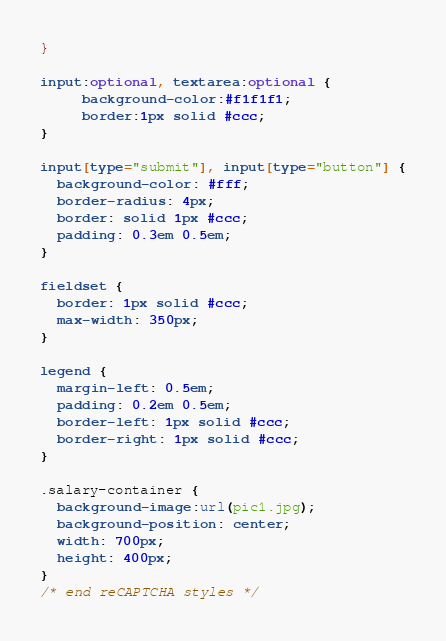<code> <loc_0><loc_0><loc_500><loc_500><_CSS_>}

input:optional, textarea:optional {
     background-color:#f1f1f1;
     border:1px solid #ccc;
}

input[type="submit"], input[type="button"] {
  background-color: #fff;
  border-radius: 4px;
  border: solid 1px #ccc;
  padding: 0.3em 0.5em;
}

fieldset {
  border: 1px solid #ccc;
  max-width: 350px;
}

legend {
  margin-left: 0.5em;
  padding: 0.2em 0.5em;
  border-left: 1px solid #ccc;
  border-right: 1px solid #ccc;
}

.salary-container {
  background-image:url(pic1.jpg);
  background-position: center;
  width: 700px;
  height: 400px;
}
/* end reCAPTCHA styles */</code> 